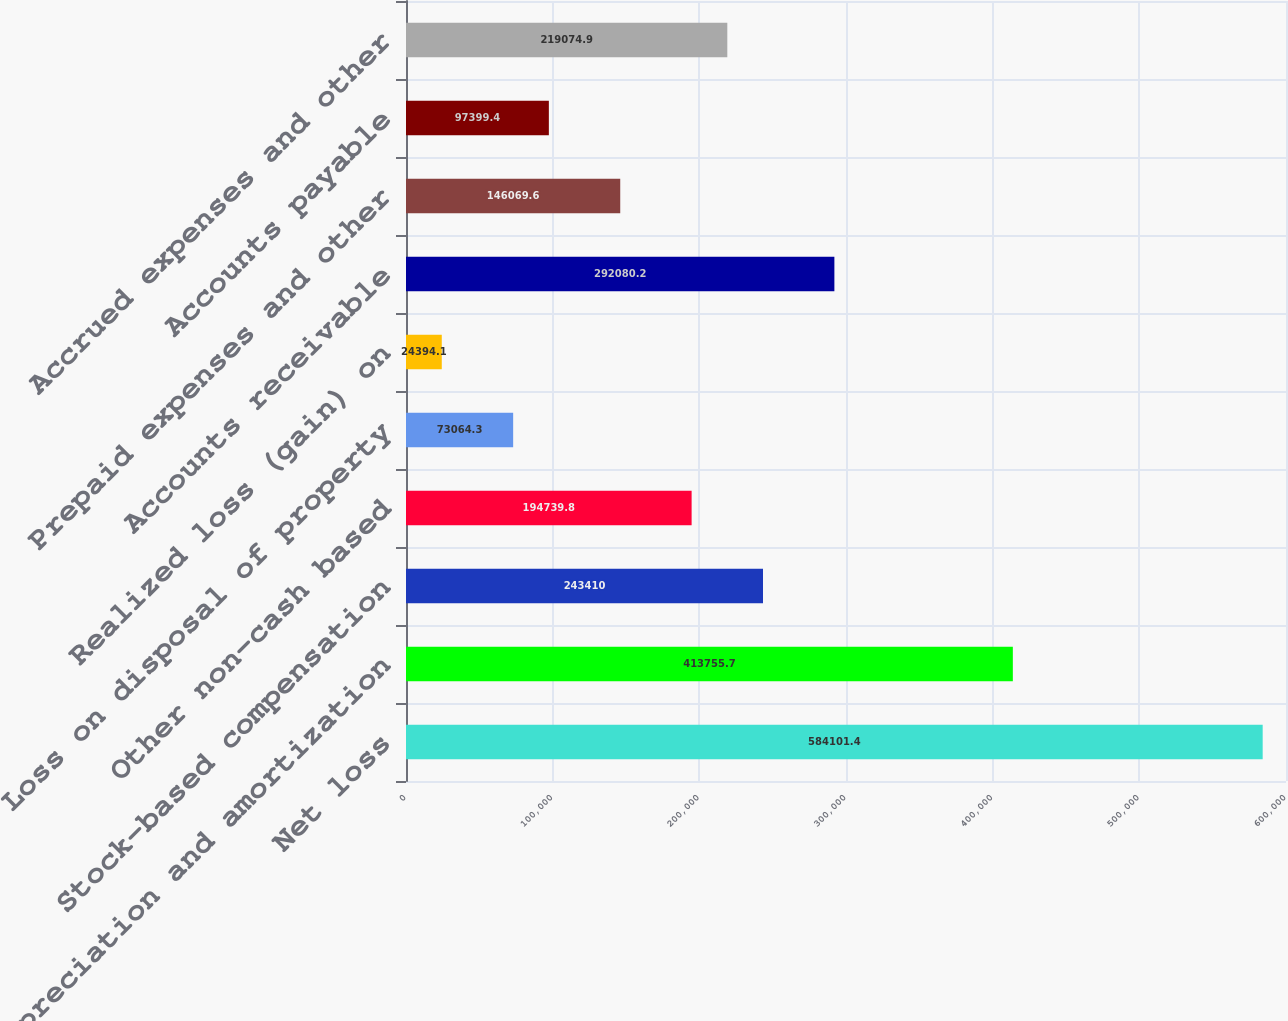<chart> <loc_0><loc_0><loc_500><loc_500><bar_chart><fcel>Net loss<fcel>Depreciation and amortization<fcel>Stock-based compensation<fcel>Other non-cash based<fcel>Loss on disposal of property<fcel>Realized loss (gain) on<fcel>Accounts receivable<fcel>Prepaid expenses and other<fcel>Accounts payable<fcel>Accrued expenses and other<nl><fcel>584101<fcel>413756<fcel>243410<fcel>194740<fcel>73064.3<fcel>24394.1<fcel>292080<fcel>146070<fcel>97399.4<fcel>219075<nl></chart> 